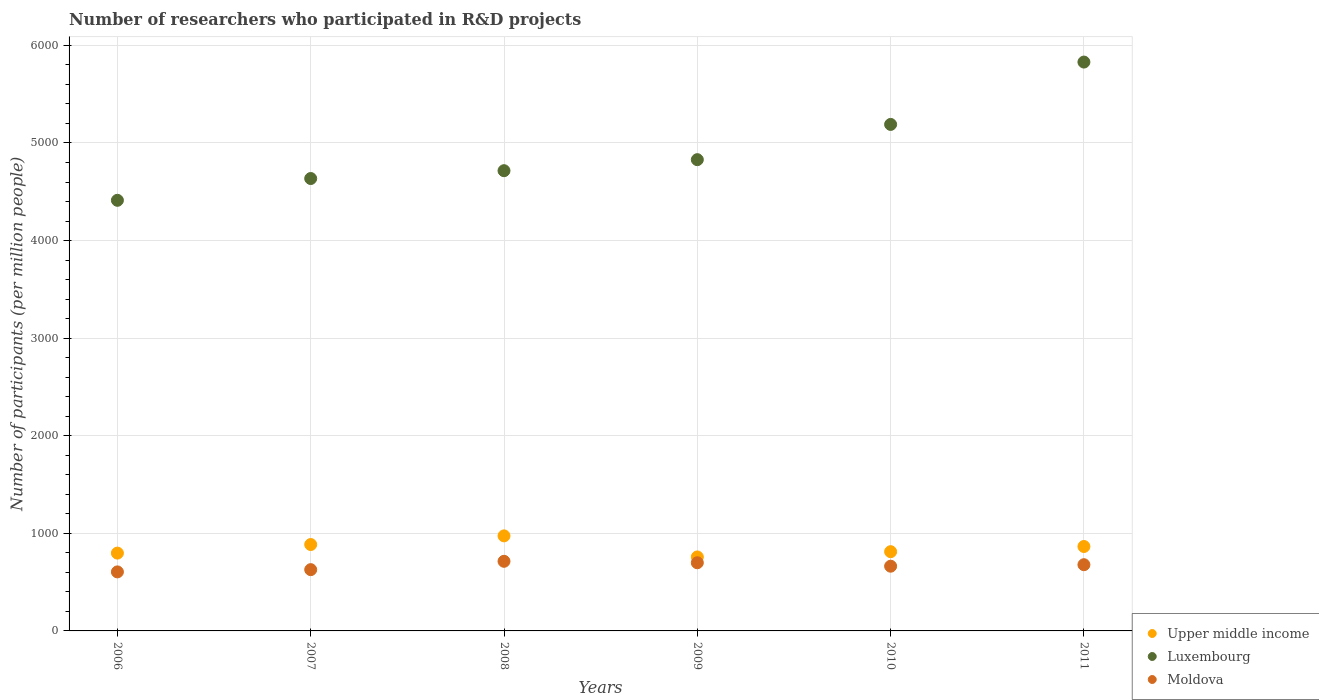How many different coloured dotlines are there?
Ensure brevity in your answer.  3. What is the number of researchers who participated in R&D projects in Upper middle income in 2009?
Give a very brief answer. 758.08. Across all years, what is the maximum number of researchers who participated in R&D projects in Luxembourg?
Keep it short and to the point. 5829.06. Across all years, what is the minimum number of researchers who participated in R&D projects in Luxembourg?
Provide a succinct answer. 4412.45. In which year was the number of researchers who participated in R&D projects in Upper middle income maximum?
Your answer should be very brief. 2008. What is the total number of researchers who participated in R&D projects in Luxembourg in the graph?
Keep it short and to the point. 2.96e+04. What is the difference between the number of researchers who participated in R&D projects in Moldova in 2007 and that in 2008?
Make the answer very short. -85.59. What is the difference between the number of researchers who participated in R&D projects in Upper middle income in 2007 and the number of researchers who participated in R&D projects in Moldova in 2008?
Make the answer very short. 171.82. What is the average number of researchers who participated in R&D projects in Upper middle income per year?
Offer a terse response. 848.64. In the year 2009, what is the difference between the number of researchers who participated in R&D projects in Moldova and number of researchers who participated in R&D projects in Upper middle income?
Give a very brief answer. -59.56. In how many years, is the number of researchers who participated in R&D projects in Upper middle income greater than 3600?
Your response must be concise. 0. What is the ratio of the number of researchers who participated in R&D projects in Moldova in 2009 to that in 2011?
Offer a terse response. 1.03. Is the difference between the number of researchers who participated in R&D projects in Moldova in 2010 and 2011 greater than the difference between the number of researchers who participated in R&D projects in Upper middle income in 2010 and 2011?
Keep it short and to the point. Yes. What is the difference between the highest and the second highest number of researchers who participated in R&D projects in Upper middle income?
Make the answer very short. 88.72. What is the difference between the highest and the lowest number of researchers who participated in R&D projects in Upper middle income?
Your answer should be compact. 215.88. Is the sum of the number of researchers who participated in R&D projects in Moldova in 2009 and 2011 greater than the maximum number of researchers who participated in R&D projects in Upper middle income across all years?
Your answer should be very brief. Yes. Is the number of researchers who participated in R&D projects in Moldova strictly greater than the number of researchers who participated in R&D projects in Luxembourg over the years?
Your response must be concise. No. How many dotlines are there?
Provide a succinct answer. 3. Are the values on the major ticks of Y-axis written in scientific E-notation?
Keep it short and to the point. No. Does the graph contain grids?
Provide a short and direct response. Yes. What is the title of the graph?
Your answer should be very brief. Number of researchers who participated in R&D projects. Does "Mexico" appear as one of the legend labels in the graph?
Offer a very short reply. No. What is the label or title of the X-axis?
Offer a terse response. Years. What is the label or title of the Y-axis?
Provide a succinct answer. Number of participants (per million people). What is the Number of participants (per million people) of Upper middle income in 2006?
Provide a succinct answer. 797.38. What is the Number of participants (per million people) of Luxembourg in 2006?
Provide a short and direct response. 4412.45. What is the Number of participants (per million people) of Moldova in 2006?
Your answer should be compact. 604.88. What is the Number of participants (per million people) of Upper middle income in 2007?
Ensure brevity in your answer.  885.24. What is the Number of participants (per million people) in Luxembourg in 2007?
Provide a short and direct response. 4635.72. What is the Number of participants (per million people) in Moldova in 2007?
Keep it short and to the point. 627.84. What is the Number of participants (per million people) of Upper middle income in 2008?
Your answer should be very brief. 973.96. What is the Number of participants (per million people) in Luxembourg in 2008?
Provide a succinct answer. 4715.93. What is the Number of participants (per million people) of Moldova in 2008?
Give a very brief answer. 713.42. What is the Number of participants (per million people) of Upper middle income in 2009?
Your answer should be compact. 758.08. What is the Number of participants (per million people) in Luxembourg in 2009?
Offer a terse response. 4828.95. What is the Number of participants (per million people) in Moldova in 2009?
Your answer should be very brief. 698.52. What is the Number of participants (per million people) of Upper middle income in 2010?
Offer a very short reply. 812.01. What is the Number of participants (per million people) in Luxembourg in 2010?
Make the answer very short. 5190.11. What is the Number of participants (per million people) of Moldova in 2010?
Give a very brief answer. 663.24. What is the Number of participants (per million people) in Upper middle income in 2011?
Offer a very short reply. 865.17. What is the Number of participants (per million people) of Luxembourg in 2011?
Your answer should be very brief. 5829.06. What is the Number of participants (per million people) of Moldova in 2011?
Offer a terse response. 678.55. Across all years, what is the maximum Number of participants (per million people) of Upper middle income?
Provide a short and direct response. 973.96. Across all years, what is the maximum Number of participants (per million people) in Luxembourg?
Your answer should be very brief. 5829.06. Across all years, what is the maximum Number of participants (per million people) in Moldova?
Your answer should be very brief. 713.42. Across all years, what is the minimum Number of participants (per million people) in Upper middle income?
Ensure brevity in your answer.  758.08. Across all years, what is the minimum Number of participants (per million people) of Luxembourg?
Give a very brief answer. 4412.45. Across all years, what is the minimum Number of participants (per million people) of Moldova?
Provide a succinct answer. 604.88. What is the total Number of participants (per million people) of Upper middle income in the graph?
Your answer should be very brief. 5091.85. What is the total Number of participants (per million people) of Luxembourg in the graph?
Your response must be concise. 2.96e+04. What is the total Number of participants (per million people) of Moldova in the graph?
Offer a terse response. 3986.45. What is the difference between the Number of participants (per million people) in Upper middle income in 2006 and that in 2007?
Provide a short and direct response. -87.86. What is the difference between the Number of participants (per million people) of Luxembourg in 2006 and that in 2007?
Ensure brevity in your answer.  -223.27. What is the difference between the Number of participants (per million people) of Moldova in 2006 and that in 2007?
Offer a very short reply. -22.96. What is the difference between the Number of participants (per million people) of Upper middle income in 2006 and that in 2008?
Give a very brief answer. -176.58. What is the difference between the Number of participants (per million people) of Luxembourg in 2006 and that in 2008?
Keep it short and to the point. -303.48. What is the difference between the Number of participants (per million people) in Moldova in 2006 and that in 2008?
Keep it short and to the point. -108.55. What is the difference between the Number of participants (per million people) in Upper middle income in 2006 and that in 2009?
Your answer should be very brief. 39.31. What is the difference between the Number of participants (per million people) in Luxembourg in 2006 and that in 2009?
Give a very brief answer. -416.5. What is the difference between the Number of participants (per million people) of Moldova in 2006 and that in 2009?
Your answer should be compact. -93.64. What is the difference between the Number of participants (per million people) in Upper middle income in 2006 and that in 2010?
Give a very brief answer. -14.63. What is the difference between the Number of participants (per million people) in Luxembourg in 2006 and that in 2010?
Your answer should be compact. -777.66. What is the difference between the Number of participants (per million people) in Moldova in 2006 and that in 2010?
Your answer should be very brief. -58.37. What is the difference between the Number of participants (per million people) of Upper middle income in 2006 and that in 2011?
Your answer should be very brief. -67.79. What is the difference between the Number of participants (per million people) of Luxembourg in 2006 and that in 2011?
Keep it short and to the point. -1416.61. What is the difference between the Number of participants (per million people) in Moldova in 2006 and that in 2011?
Give a very brief answer. -73.67. What is the difference between the Number of participants (per million people) of Upper middle income in 2007 and that in 2008?
Your answer should be compact. -88.72. What is the difference between the Number of participants (per million people) of Luxembourg in 2007 and that in 2008?
Your response must be concise. -80.21. What is the difference between the Number of participants (per million people) in Moldova in 2007 and that in 2008?
Provide a short and direct response. -85.59. What is the difference between the Number of participants (per million people) of Upper middle income in 2007 and that in 2009?
Your response must be concise. 127.16. What is the difference between the Number of participants (per million people) in Luxembourg in 2007 and that in 2009?
Your response must be concise. -193.23. What is the difference between the Number of participants (per million people) in Moldova in 2007 and that in 2009?
Provide a short and direct response. -70.68. What is the difference between the Number of participants (per million people) in Upper middle income in 2007 and that in 2010?
Give a very brief answer. 73.23. What is the difference between the Number of participants (per million people) of Luxembourg in 2007 and that in 2010?
Ensure brevity in your answer.  -554.39. What is the difference between the Number of participants (per million people) in Moldova in 2007 and that in 2010?
Your answer should be very brief. -35.4. What is the difference between the Number of participants (per million people) in Upper middle income in 2007 and that in 2011?
Offer a terse response. 20.07. What is the difference between the Number of participants (per million people) of Luxembourg in 2007 and that in 2011?
Your answer should be compact. -1193.34. What is the difference between the Number of participants (per million people) in Moldova in 2007 and that in 2011?
Provide a short and direct response. -50.71. What is the difference between the Number of participants (per million people) in Upper middle income in 2008 and that in 2009?
Keep it short and to the point. 215.88. What is the difference between the Number of participants (per million people) in Luxembourg in 2008 and that in 2009?
Your answer should be very brief. -113.02. What is the difference between the Number of participants (per million people) of Moldova in 2008 and that in 2009?
Your response must be concise. 14.9. What is the difference between the Number of participants (per million people) in Upper middle income in 2008 and that in 2010?
Your response must be concise. 161.95. What is the difference between the Number of participants (per million people) of Luxembourg in 2008 and that in 2010?
Make the answer very short. -474.18. What is the difference between the Number of participants (per million people) in Moldova in 2008 and that in 2010?
Provide a short and direct response. 50.18. What is the difference between the Number of participants (per million people) of Upper middle income in 2008 and that in 2011?
Make the answer very short. 108.79. What is the difference between the Number of participants (per million people) of Luxembourg in 2008 and that in 2011?
Offer a very short reply. -1113.13. What is the difference between the Number of participants (per million people) in Moldova in 2008 and that in 2011?
Ensure brevity in your answer.  34.87. What is the difference between the Number of participants (per million people) in Upper middle income in 2009 and that in 2010?
Give a very brief answer. -53.94. What is the difference between the Number of participants (per million people) of Luxembourg in 2009 and that in 2010?
Offer a very short reply. -361.16. What is the difference between the Number of participants (per million people) of Moldova in 2009 and that in 2010?
Your response must be concise. 35.28. What is the difference between the Number of participants (per million people) in Upper middle income in 2009 and that in 2011?
Give a very brief answer. -107.09. What is the difference between the Number of participants (per million people) of Luxembourg in 2009 and that in 2011?
Provide a short and direct response. -1000.11. What is the difference between the Number of participants (per million people) in Moldova in 2009 and that in 2011?
Offer a very short reply. 19.97. What is the difference between the Number of participants (per million people) in Upper middle income in 2010 and that in 2011?
Ensure brevity in your answer.  -53.16. What is the difference between the Number of participants (per million people) in Luxembourg in 2010 and that in 2011?
Provide a succinct answer. -638.95. What is the difference between the Number of participants (per million people) in Moldova in 2010 and that in 2011?
Keep it short and to the point. -15.31. What is the difference between the Number of participants (per million people) in Upper middle income in 2006 and the Number of participants (per million people) in Luxembourg in 2007?
Keep it short and to the point. -3838.34. What is the difference between the Number of participants (per million people) in Upper middle income in 2006 and the Number of participants (per million people) in Moldova in 2007?
Your answer should be compact. 169.55. What is the difference between the Number of participants (per million people) in Luxembourg in 2006 and the Number of participants (per million people) in Moldova in 2007?
Offer a terse response. 3784.62. What is the difference between the Number of participants (per million people) of Upper middle income in 2006 and the Number of participants (per million people) of Luxembourg in 2008?
Your answer should be very brief. -3918.55. What is the difference between the Number of participants (per million people) in Upper middle income in 2006 and the Number of participants (per million people) in Moldova in 2008?
Provide a succinct answer. 83.96. What is the difference between the Number of participants (per million people) of Luxembourg in 2006 and the Number of participants (per million people) of Moldova in 2008?
Your answer should be compact. 3699.03. What is the difference between the Number of participants (per million people) of Upper middle income in 2006 and the Number of participants (per million people) of Luxembourg in 2009?
Offer a very short reply. -4031.57. What is the difference between the Number of participants (per million people) in Upper middle income in 2006 and the Number of participants (per million people) in Moldova in 2009?
Give a very brief answer. 98.86. What is the difference between the Number of participants (per million people) of Luxembourg in 2006 and the Number of participants (per million people) of Moldova in 2009?
Make the answer very short. 3713.94. What is the difference between the Number of participants (per million people) of Upper middle income in 2006 and the Number of participants (per million people) of Luxembourg in 2010?
Keep it short and to the point. -4392.73. What is the difference between the Number of participants (per million people) in Upper middle income in 2006 and the Number of participants (per million people) in Moldova in 2010?
Your answer should be very brief. 134.14. What is the difference between the Number of participants (per million people) in Luxembourg in 2006 and the Number of participants (per million people) in Moldova in 2010?
Your answer should be compact. 3749.21. What is the difference between the Number of participants (per million people) of Upper middle income in 2006 and the Number of participants (per million people) of Luxembourg in 2011?
Offer a very short reply. -5031.68. What is the difference between the Number of participants (per million people) in Upper middle income in 2006 and the Number of participants (per million people) in Moldova in 2011?
Give a very brief answer. 118.83. What is the difference between the Number of participants (per million people) of Luxembourg in 2006 and the Number of participants (per million people) of Moldova in 2011?
Offer a very short reply. 3733.9. What is the difference between the Number of participants (per million people) of Upper middle income in 2007 and the Number of participants (per million people) of Luxembourg in 2008?
Ensure brevity in your answer.  -3830.69. What is the difference between the Number of participants (per million people) in Upper middle income in 2007 and the Number of participants (per million people) in Moldova in 2008?
Your answer should be compact. 171.82. What is the difference between the Number of participants (per million people) in Luxembourg in 2007 and the Number of participants (per million people) in Moldova in 2008?
Provide a short and direct response. 3922.3. What is the difference between the Number of participants (per million people) in Upper middle income in 2007 and the Number of participants (per million people) in Luxembourg in 2009?
Offer a very short reply. -3943.71. What is the difference between the Number of participants (per million people) of Upper middle income in 2007 and the Number of participants (per million people) of Moldova in 2009?
Offer a terse response. 186.72. What is the difference between the Number of participants (per million people) in Luxembourg in 2007 and the Number of participants (per million people) in Moldova in 2009?
Offer a terse response. 3937.2. What is the difference between the Number of participants (per million people) in Upper middle income in 2007 and the Number of participants (per million people) in Luxembourg in 2010?
Ensure brevity in your answer.  -4304.87. What is the difference between the Number of participants (per million people) in Upper middle income in 2007 and the Number of participants (per million people) in Moldova in 2010?
Offer a terse response. 222. What is the difference between the Number of participants (per million people) in Luxembourg in 2007 and the Number of participants (per million people) in Moldova in 2010?
Give a very brief answer. 3972.48. What is the difference between the Number of participants (per million people) in Upper middle income in 2007 and the Number of participants (per million people) in Luxembourg in 2011?
Provide a succinct answer. -4943.82. What is the difference between the Number of participants (per million people) in Upper middle income in 2007 and the Number of participants (per million people) in Moldova in 2011?
Offer a very short reply. 206.69. What is the difference between the Number of participants (per million people) of Luxembourg in 2007 and the Number of participants (per million people) of Moldova in 2011?
Provide a succinct answer. 3957.17. What is the difference between the Number of participants (per million people) of Upper middle income in 2008 and the Number of participants (per million people) of Luxembourg in 2009?
Ensure brevity in your answer.  -3854.99. What is the difference between the Number of participants (per million people) in Upper middle income in 2008 and the Number of participants (per million people) in Moldova in 2009?
Your answer should be compact. 275.44. What is the difference between the Number of participants (per million people) of Luxembourg in 2008 and the Number of participants (per million people) of Moldova in 2009?
Ensure brevity in your answer.  4017.41. What is the difference between the Number of participants (per million people) in Upper middle income in 2008 and the Number of participants (per million people) in Luxembourg in 2010?
Make the answer very short. -4216.15. What is the difference between the Number of participants (per million people) of Upper middle income in 2008 and the Number of participants (per million people) of Moldova in 2010?
Offer a terse response. 310.72. What is the difference between the Number of participants (per million people) of Luxembourg in 2008 and the Number of participants (per million people) of Moldova in 2010?
Your answer should be very brief. 4052.69. What is the difference between the Number of participants (per million people) of Upper middle income in 2008 and the Number of participants (per million people) of Luxembourg in 2011?
Provide a short and direct response. -4855.1. What is the difference between the Number of participants (per million people) of Upper middle income in 2008 and the Number of participants (per million people) of Moldova in 2011?
Ensure brevity in your answer.  295.41. What is the difference between the Number of participants (per million people) in Luxembourg in 2008 and the Number of participants (per million people) in Moldova in 2011?
Make the answer very short. 4037.38. What is the difference between the Number of participants (per million people) in Upper middle income in 2009 and the Number of participants (per million people) in Luxembourg in 2010?
Give a very brief answer. -4432.03. What is the difference between the Number of participants (per million people) of Upper middle income in 2009 and the Number of participants (per million people) of Moldova in 2010?
Provide a succinct answer. 94.84. What is the difference between the Number of participants (per million people) of Luxembourg in 2009 and the Number of participants (per million people) of Moldova in 2010?
Offer a terse response. 4165.71. What is the difference between the Number of participants (per million people) of Upper middle income in 2009 and the Number of participants (per million people) of Luxembourg in 2011?
Provide a succinct answer. -5070.98. What is the difference between the Number of participants (per million people) of Upper middle income in 2009 and the Number of participants (per million people) of Moldova in 2011?
Your answer should be very brief. 79.53. What is the difference between the Number of participants (per million people) in Luxembourg in 2009 and the Number of participants (per million people) in Moldova in 2011?
Your answer should be very brief. 4150.4. What is the difference between the Number of participants (per million people) of Upper middle income in 2010 and the Number of participants (per million people) of Luxembourg in 2011?
Ensure brevity in your answer.  -5017.05. What is the difference between the Number of participants (per million people) in Upper middle income in 2010 and the Number of participants (per million people) in Moldova in 2011?
Make the answer very short. 133.46. What is the difference between the Number of participants (per million people) of Luxembourg in 2010 and the Number of participants (per million people) of Moldova in 2011?
Your response must be concise. 4511.56. What is the average Number of participants (per million people) of Upper middle income per year?
Give a very brief answer. 848.64. What is the average Number of participants (per million people) in Luxembourg per year?
Make the answer very short. 4935.37. What is the average Number of participants (per million people) of Moldova per year?
Keep it short and to the point. 664.41. In the year 2006, what is the difference between the Number of participants (per million people) of Upper middle income and Number of participants (per million people) of Luxembourg?
Provide a succinct answer. -3615.07. In the year 2006, what is the difference between the Number of participants (per million people) in Upper middle income and Number of participants (per million people) in Moldova?
Your answer should be compact. 192.51. In the year 2006, what is the difference between the Number of participants (per million people) in Luxembourg and Number of participants (per million people) in Moldova?
Make the answer very short. 3807.58. In the year 2007, what is the difference between the Number of participants (per million people) of Upper middle income and Number of participants (per million people) of Luxembourg?
Make the answer very short. -3750.48. In the year 2007, what is the difference between the Number of participants (per million people) of Upper middle income and Number of participants (per million people) of Moldova?
Make the answer very short. 257.4. In the year 2007, what is the difference between the Number of participants (per million people) in Luxembourg and Number of participants (per million people) in Moldova?
Your answer should be compact. 4007.88. In the year 2008, what is the difference between the Number of participants (per million people) in Upper middle income and Number of participants (per million people) in Luxembourg?
Your response must be concise. -3741.97. In the year 2008, what is the difference between the Number of participants (per million people) of Upper middle income and Number of participants (per million people) of Moldova?
Ensure brevity in your answer.  260.54. In the year 2008, what is the difference between the Number of participants (per million people) of Luxembourg and Number of participants (per million people) of Moldova?
Keep it short and to the point. 4002.51. In the year 2009, what is the difference between the Number of participants (per million people) of Upper middle income and Number of participants (per million people) of Luxembourg?
Ensure brevity in your answer.  -4070.87. In the year 2009, what is the difference between the Number of participants (per million people) of Upper middle income and Number of participants (per million people) of Moldova?
Your answer should be very brief. 59.56. In the year 2009, what is the difference between the Number of participants (per million people) in Luxembourg and Number of participants (per million people) in Moldova?
Your response must be concise. 4130.43. In the year 2010, what is the difference between the Number of participants (per million people) of Upper middle income and Number of participants (per million people) of Luxembourg?
Ensure brevity in your answer.  -4378.1. In the year 2010, what is the difference between the Number of participants (per million people) of Upper middle income and Number of participants (per million people) of Moldova?
Your response must be concise. 148.77. In the year 2010, what is the difference between the Number of participants (per million people) of Luxembourg and Number of participants (per million people) of Moldova?
Provide a short and direct response. 4526.87. In the year 2011, what is the difference between the Number of participants (per million people) in Upper middle income and Number of participants (per million people) in Luxembourg?
Offer a very short reply. -4963.89. In the year 2011, what is the difference between the Number of participants (per million people) in Upper middle income and Number of participants (per million people) in Moldova?
Ensure brevity in your answer.  186.62. In the year 2011, what is the difference between the Number of participants (per million people) of Luxembourg and Number of participants (per million people) of Moldova?
Make the answer very short. 5150.51. What is the ratio of the Number of participants (per million people) in Upper middle income in 2006 to that in 2007?
Provide a succinct answer. 0.9. What is the ratio of the Number of participants (per million people) of Luxembourg in 2006 to that in 2007?
Offer a very short reply. 0.95. What is the ratio of the Number of participants (per million people) in Moldova in 2006 to that in 2007?
Your answer should be very brief. 0.96. What is the ratio of the Number of participants (per million people) in Upper middle income in 2006 to that in 2008?
Keep it short and to the point. 0.82. What is the ratio of the Number of participants (per million people) of Luxembourg in 2006 to that in 2008?
Ensure brevity in your answer.  0.94. What is the ratio of the Number of participants (per million people) in Moldova in 2006 to that in 2008?
Offer a very short reply. 0.85. What is the ratio of the Number of participants (per million people) in Upper middle income in 2006 to that in 2009?
Your answer should be very brief. 1.05. What is the ratio of the Number of participants (per million people) of Luxembourg in 2006 to that in 2009?
Make the answer very short. 0.91. What is the ratio of the Number of participants (per million people) in Moldova in 2006 to that in 2009?
Give a very brief answer. 0.87. What is the ratio of the Number of participants (per million people) in Upper middle income in 2006 to that in 2010?
Keep it short and to the point. 0.98. What is the ratio of the Number of participants (per million people) of Luxembourg in 2006 to that in 2010?
Your answer should be compact. 0.85. What is the ratio of the Number of participants (per million people) in Moldova in 2006 to that in 2010?
Give a very brief answer. 0.91. What is the ratio of the Number of participants (per million people) in Upper middle income in 2006 to that in 2011?
Your response must be concise. 0.92. What is the ratio of the Number of participants (per million people) of Luxembourg in 2006 to that in 2011?
Your answer should be very brief. 0.76. What is the ratio of the Number of participants (per million people) of Moldova in 2006 to that in 2011?
Provide a short and direct response. 0.89. What is the ratio of the Number of participants (per million people) of Upper middle income in 2007 to that in 2008?
Your answer should be compact. 0.91. What is the ratio of the Number of participants (per million people) in Luxembourg in 2007 to that in 2008?
Provide a succinct answer. 0.98. What is the ratio of the Number of participants (per million people) of Upper middle income in 2007 to that in 2009?
Your response must be concise. 1.17. What is the ratio of the Number of participants (per million people) of Luxembourg in 2007 to that in 2009?
Give a very brief answer. 0.96. What is the ratio of the Number of participants (per million people) of Moldova in 2007 to that in 2009?
Provide a succinct answer. 0.9. What is the ratio of the Number of participants (per million people) in Upper middle income in 2007 to that in 2010?
Make the answer very short. 1.09. What is the ratio of the Number of participants (per million people) in Luxembourg in 2007 to that in 2010?
Offer a very short reply. 0.89. What is the ratio of the Number of participants (per million people) of Moldova in 2007 to that in 2010?
Your answer should be compact. 0.95. What is the ratio of the Number of participants (per million people) of Upper middle income in 2007 to that in 2011?
Your answer should be very brief. 1.02. What is the ratio of the Number of participants (per million people) in Luxembourg in 2007 to that in 2011?
Give a very brief answer. 0.8. What is the ratio of the Number of participants (per million people) in Moldova in 2007 to that in 2011?
Offer a terse response. 0.93. What is the ratio of the Number of participants (per million people) of Upper middle income in 2008 to that in 2009?
Offer a terse response. 1.28. What is the ratio of the Number of participants (per million people) of Luxembourg in 2008 to that in 2009?
Offer a very short reply. 0.98. What is the ratio of the Number of participants (per million people) in Moldova in 2008 to that in 2009?
Offer a very short reply. 1.02. What is the ratio of the Number of participants (per million people) of Upper middle income in 2008 to that in 2010?
Provide a short and direct response. 1.2. What is the ratio of the Number of participants (per million people) of Luxembourg in 2008 to that in 2010?
Give a very brief answer. 0.91. What is the ratio of the Number of participants (per million people) in Moldova in 2008 to that in 2010?
Provide a short and direct response. 1.08. What is the ratio of the Number of participants (per million people) in Upper middle income in 2008 to that in 2011?
Your answer should be very brief. 1.13. What is the ratio of the Number of participants (per million people) in Luxembourg in 2008 to that in 2011?
Provide a succinct answer. 0.81. What is the ratio of the Number of participants (per million people) of Moldova in 2008 to that in 2011?
Provide a succinct answer. 1.05. What is the ratio of the Number of participants (per million people) in Upper middle income in 2009 to that in 2010?
Give a very brief answer. 0.93. What is the ratio of the Number of participants (per million people) of Luxembourg in 2009 to that in 2010?
Your response must be concise. 0.93. What is the ratio of the Number of participants (per million people) of Moldova in 2009 to that in 2010?
Ensure brevity in your answer.  1.05. What is the ratio of the Number of participants (per million people) in Upper middle income in 2009 to that in 2011?
Your answer should be compact. 0.88. What is the ratio of the Number of participants (per million people) in Luxembourg in 2009 to that in 2011?
Offer a terse response. 0.83. What is the ratio of the Number of participants (per million people) in Moldova in 2009 to that in 2011?
Your answer should be compact. 1.03. What is the ratio of the Number of participants (per million people) of Upper middle income in 2010 to that in 2011?
Keep it short and to the point. 0.94. What is the ratio of the Number of participants (per million people) in Luxembourg in 2010 to that in 2011?
Make the answer very short. 0.89. What is the ratio of the Number of participants (per million people) in Moldova in 2010 to that in 2011?
Make the answer very short. 0.98. What is the difference between the highest and the second highest Number of participants (per million people) in Upper middle income?
Your answer should be very brief. 88.72. What is the difference between the highest and the second highest Number of participants (per million people) of Luxembourg?
Your answer should be compact. 638.95. What is the difference between the highest and the second highest Number of participants (per million people) of Moldova?
Provide a succinct answer. 14.9. What is the difference between the highest and the lowest Number of participants (per million people) in Upper middle income?
Your response must be concise. 215.88. What is the difference between the highest and the lowest Number of participants (per million people) in Luxembourg?
Provide a short and direct response. 1416.61. What is the difference between the highest and the lowest Number of participants (per million people) of Moldova?
Your answer should be compact. 108.55. 